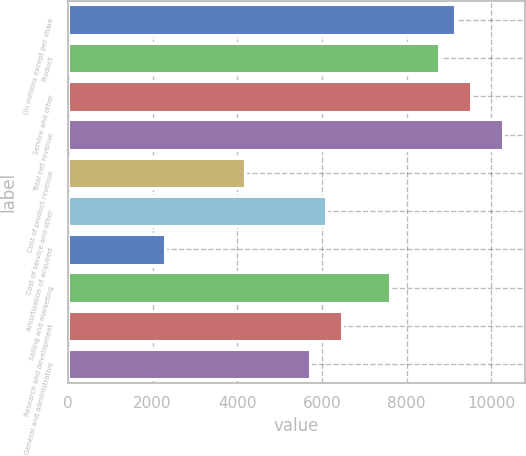Convert chart to OTSL. <chart><loc_0><loc_0><loc_500><loc_500><bar_chart><fcel>(In millions except per share<fcel>Product<fcel>Service and other<fcel>Total net revenue<fcel>Cost of product revenue<fcel>Cost of service and other<fcel>Amortization of acquired<fcel>Selling and marketing<fcel>Research and development<fcel>General and administrative<nl><fcel>9139.05<fcel>8758.26<fcel>9519.84<fcel>10281.4<fcel>4188.78<fcel>6092.73<fcel>2284.83<fcel>7615.89<fcel>6473.52<fcel>5711.94<nl></chart> 